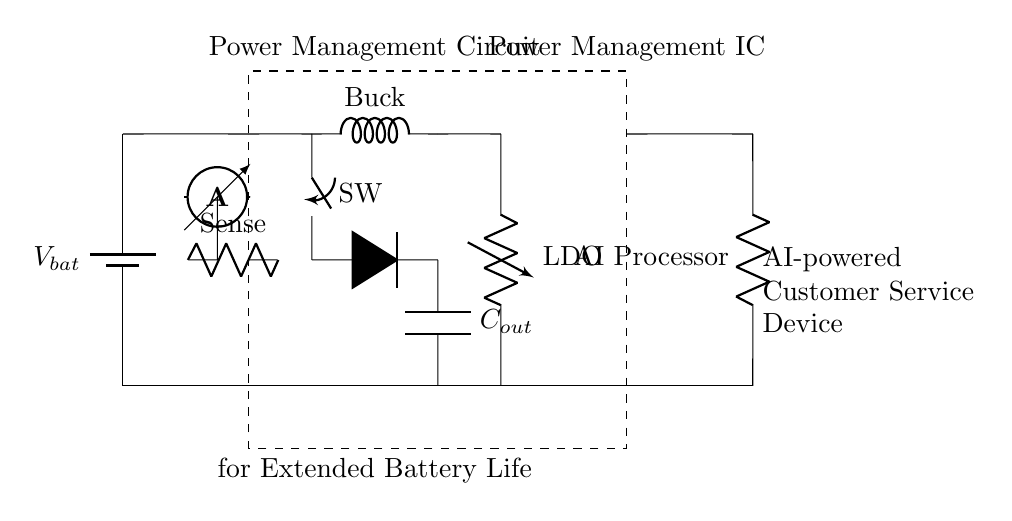What is the main component responsible for voltage regulation? The main component for voltage regulation in this circuit is the LDO, which stands for Low Drop-Out regulator. It is designed to maintain a stable output voltage despite changes in load current or input voltage.
Answer: LDO What component is used to sense current in the battery management section? The component used to sense current is labeled as "Sense," which is generally a current sensing resistor. It helps monitor the current flowing from the battery to the circuit.
Answer: Sense How many major components are within the Power Management IC? The major components within the Power Management IC include the Buck Converter, the LDO, and the sense resistor, making a total of three essential components illustrated in the diagram.
Answer: Three What happens when the switch labeled SW is closed? When the switch SW is closed, it connects the Buck Converter to the output, enabling it to provide a regulated lower voltage to the load, thereby enhancing power efficiency and extending battery life.
Answer: Provides regulated voltage Which component is responsible for energy storage in the circuit? The component responsible for energy storage in this circuit is the capacitor labeled C_out. It stores charge and helps smooth the output voltage delivered to the load.
Answer: C_out What is the function of the AI Processor in this circuit? The AI Processor serves as the load that utilizes power from the battery management circuit to operate the AI functionalities required for customer service applications.
Answer: Load Which component ensures that the output voltage remains stable during load variations? The LDO, acting as a voltage regulator, ensures that the output voltage remains stable even when there are variations in the load current due to the operation of the AI Processor.
Answer: LDO 